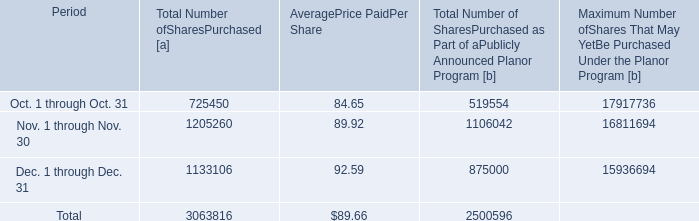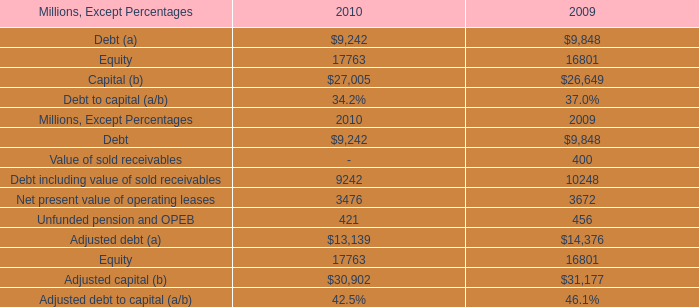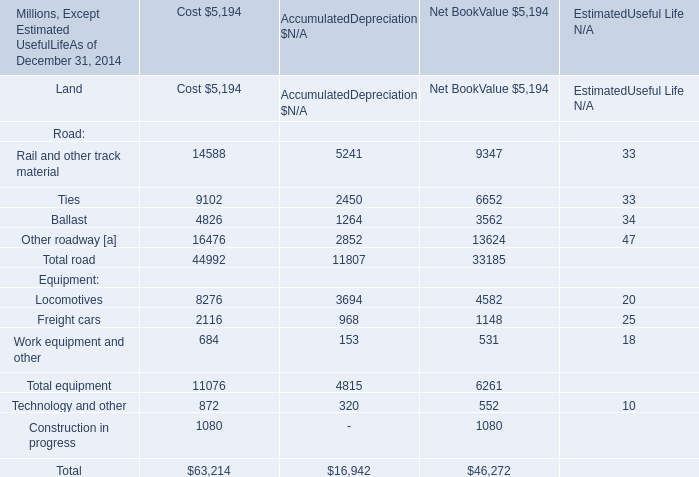how much more was spent on shares in nov 2010 than dec 2010? 
Computations: ((1205260 * 89.92) - (1133106 * 92.59))
Answer: 3462694.66. 